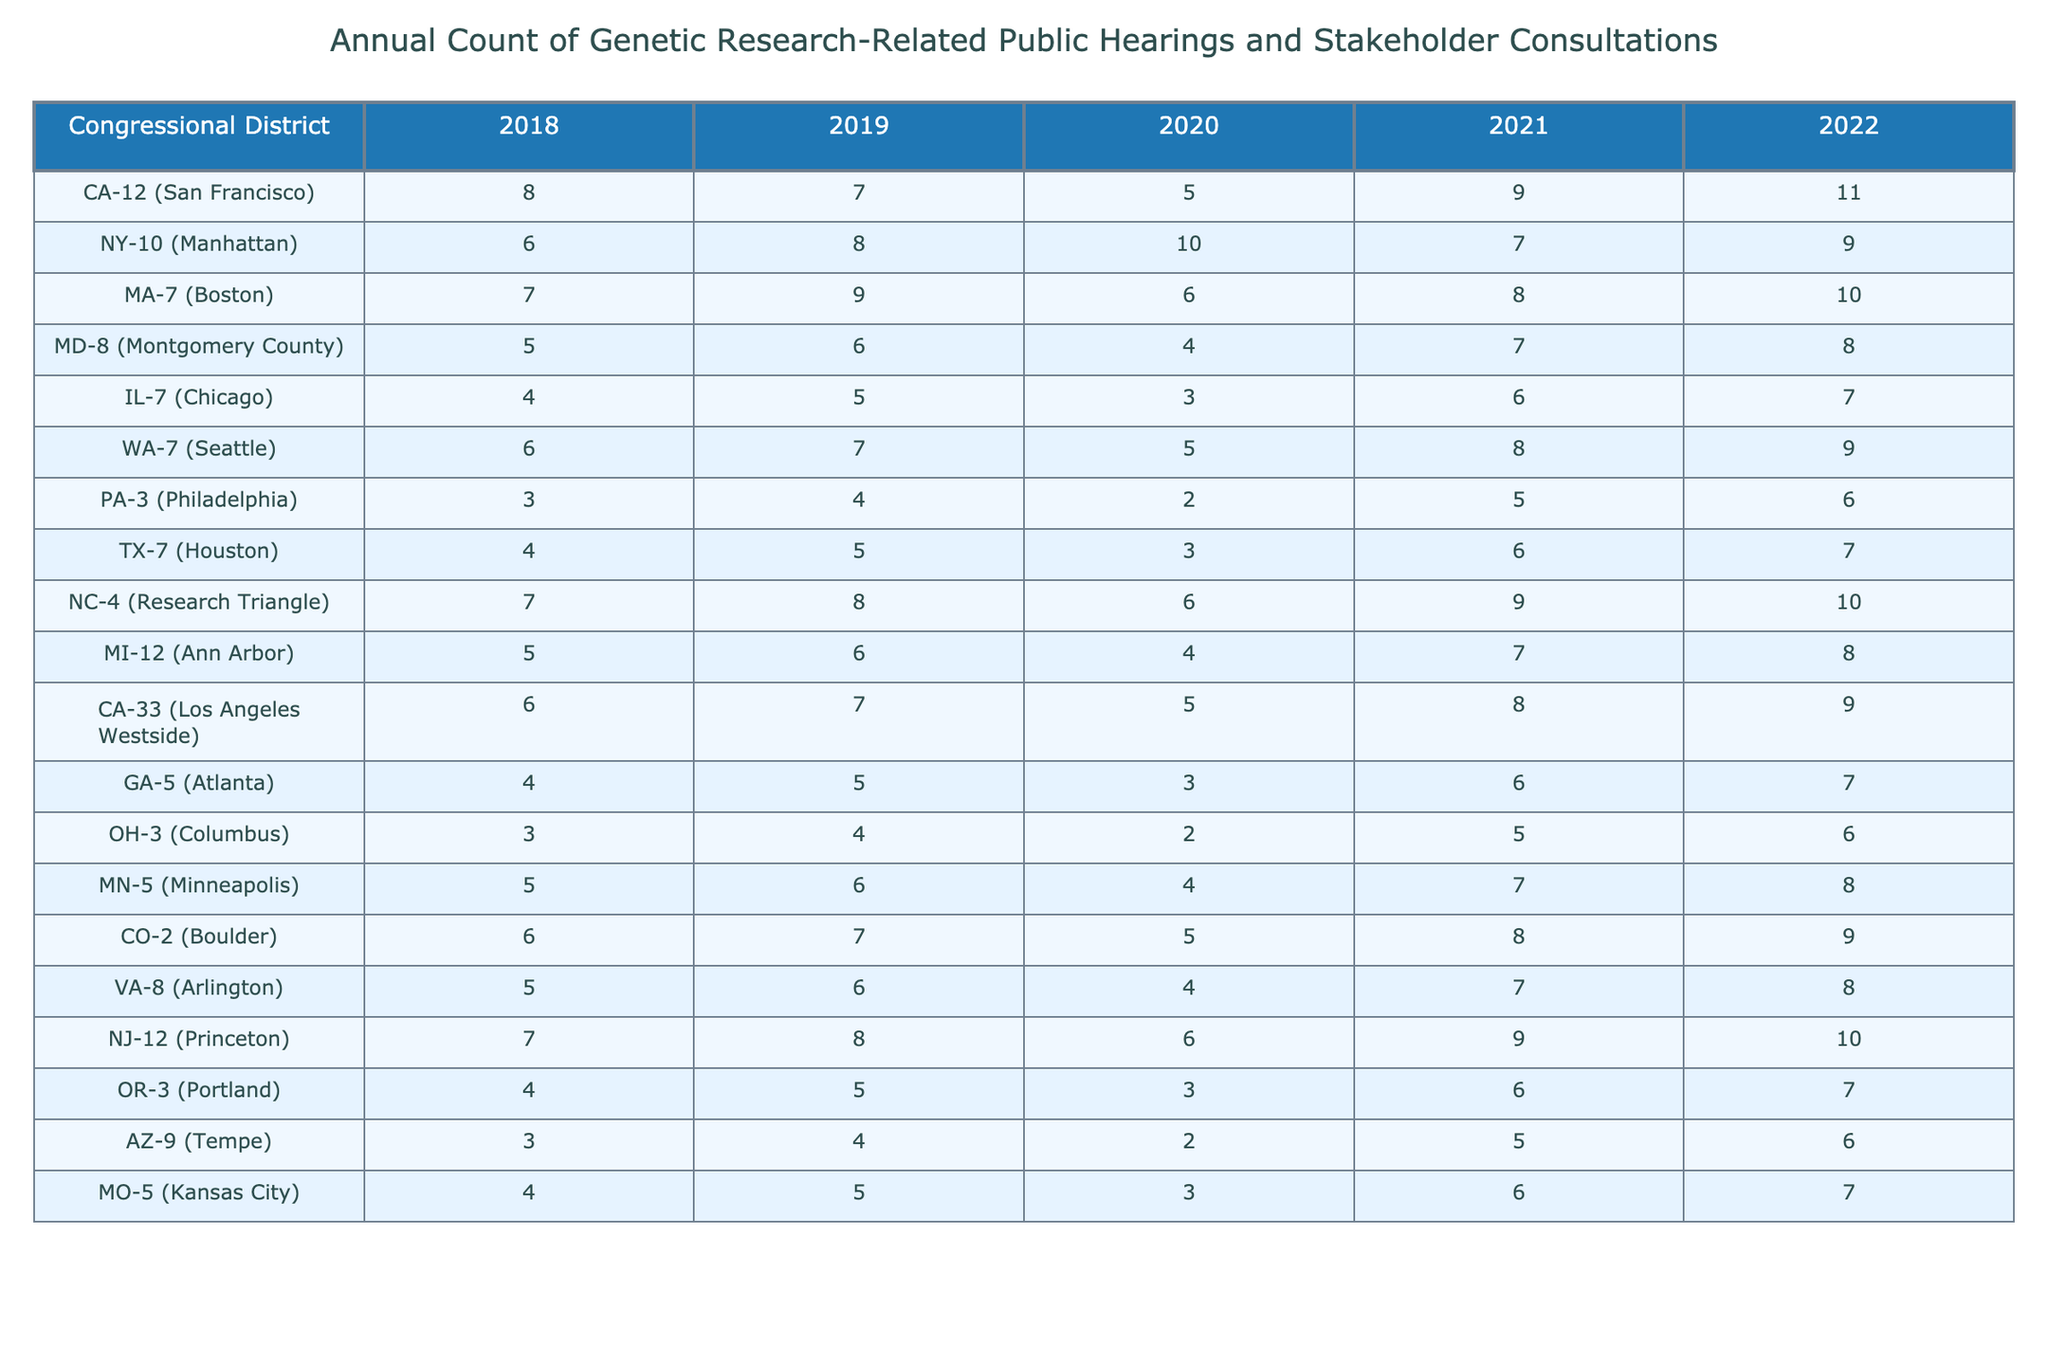What was the total number of genetic research-related public hearings in CA-12 from 2018 to 2022? Adding the values for CA-12, we sum up: 8 + 7 + 5 + 9 + 11 = 40
Answer: 40 In which year did NY-10 have the highest number of public hearings? Looking at the values for NY-10, the highest number is 10 in 2020
Answer: 2020 Which district had the least number of public hearings in 2022? The values for 2022 are: CA-12 (11), NY-10 (9), MA-7 (10), MD-8 (8), IL-7 (7), WA-7 (9), PA-3 (6), TX-7 (7), NC-4 (10), MI-12 (8), CA-33 (9), GA-5 (7), OH-3 (6), MN-5 (8), CO-2 (9), VA-8 (8), NJ-12 (10), OR-3 (7), AZ-9 (6), MO-5 (7). The least is PA-3, TX-7, OH-3, AZ-9 with 6 hearings each.
Answer: PA-3, TX-7, OH-3, AZ-9 How many more public hearings did NC-4 have in 2021 compared to 2020? For NC-4, the values are 9 in 2021 and 6 in 2020. The difference is 9 - 6 = 3
Answer: 3 What was the year with the highest average count of hearings across all districts? Calculate the average for each year: for 2018 = (8+6+7+5+4+6+3+4+7+5+6+4+3+5+6+5+7+4+3+4) / 20 = 5.05, for 2019 = (7+8+9+6+5+7+4+5+8+6+7+5+4+6+7+6+8+5+4+5) / 20 = 6.05, for 2020 = (5+10+6+4+3+5+2+3+6+4+5+3+2+4+4+4+6+3+2+3) / 20 = 4.15, for 2021 = (9+7+8+7+6+8+5+6+9+7+8+6+5+7+6+7+9+6+5+6) / 20 = 7.05, for 2022 = (11+9+10+8+7+9+6+7+10+8+9+7+6+8+9+8+10+7+6+7) / 20 = 8.05. The highest average is for 2022 at 8.05.
Answer: 2022 Did GA-5 see an increase in public hearings from 2018 to 2022? In 2018, GA-5 had 4 hearings and in 2022, it had 7, which shows an increase.
Answer: Yes Which district has the greatest increase in public hearings over the five years? The increases are: CA-12 (3), NY-10 (3), MA-7 (3), MD-8 (3), IL-7 (3), WA-7 (3), PA-3 (3), TX-7 (3), NC-4 (3), MI-12 (3), CA-33 (3), GA-5 (3), OH-3 (3), MN-5 (3), CO-2 (3), VA-8 (3), NJ-12 (3), OR-3 (3), AZ-9 (3), MO-5 (3). All listed districts had a 3 increase, but those with a different count from 2018-2022 include MD-8 (3 after 4), PA-3 (3 after 2), and others stay in the 3 range showing stable count.
Answer: Many districts saw an increase of 3 